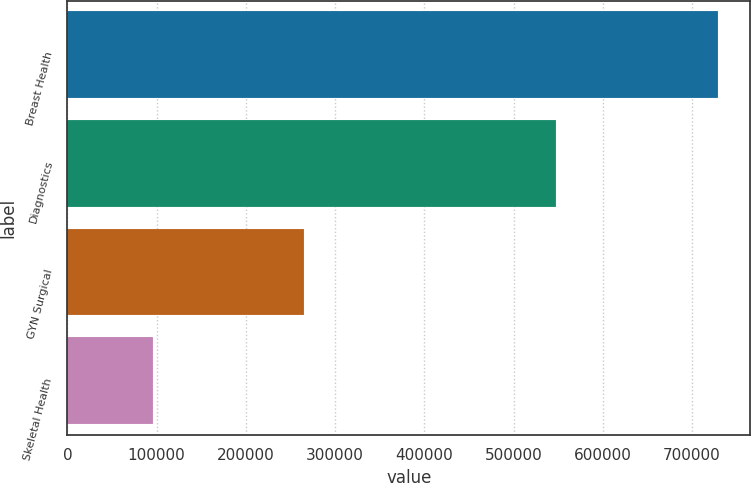Convert chart to OTSL. <chart><loc_0><loc_0><loc_500><loc_500><bar_chart><fcel>Breast Health<fcel>Diagnostics<fcel>GYN Surgical<fcel>Skeletal Health<nl><fcel>728884<fcel>547892<fcel>264900<fcel>95458<nl></chart> 